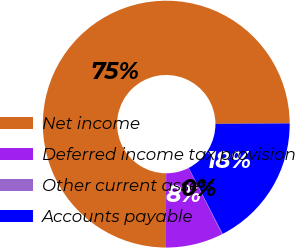Convert chart to OTSL. <chart><loc_0><loc_0><loc_500><loc_500><pie_chart><fcel>Net income<fcel>Deferred income tax provision<fcel>Other current assets<fcel>Accounts payable<nl><fcel>74.86%<fcel>7.54%<fcel>0.06%<fcel>17.54%<nl></chart> 